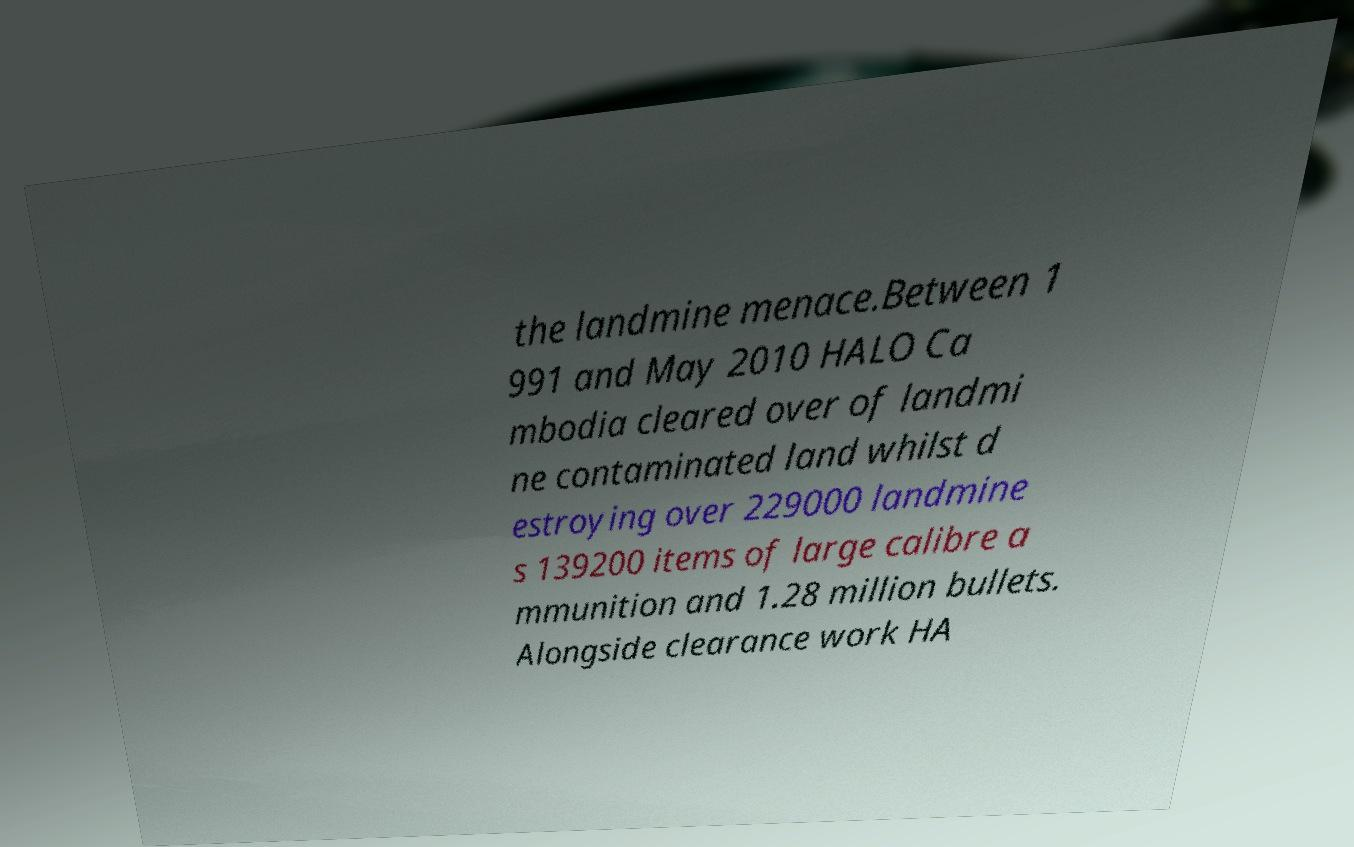I need the written content from this picture converted into text. Can you do that? the landmine menace.Between 1 991 and May 2010 HALO Ca mbodia cleared over of landmi ne contaminated land whilst d estroying over 229000 landmine s 139200 items of large calibre a mmunition and 1.28 million bullets. Alongside clearance work HA 